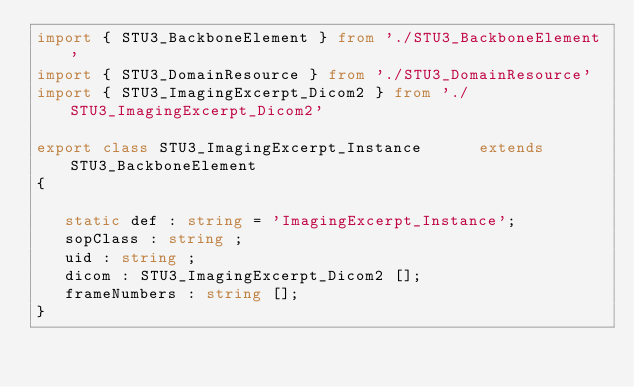Convert code to text. <code><loc_0><loc_0><loc_500><loc_500><_TypeScript_>import { STU3_BackboneElement } from './STU3_BackboneElement'
import { STU3_DomainResource } from './STU3_DomainResource'
import { STU3_ImagingExcerpt_Dicom2 } from './STU3_ImagingExcerpt_Dicom2'

export class STU3_ImagingExcerpt_Instance      extends STU3_BackboneElement
{

   static def : string = 'ImagingExcerpt_Instance';
   sopClass : string ;
   uid : string ;
   dicom : STU3_ImagingExcerpt_Dicom2 [];
   frameNumbers : string [];
}
</code> 